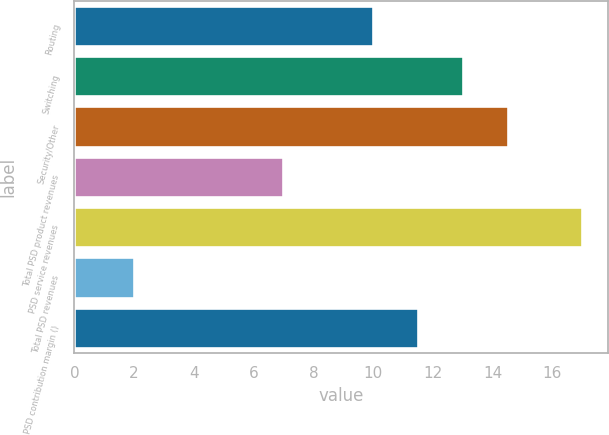Convert chart to OTSL. <chart><loc_0><loc_0><loc_500><loc_500><bar_chart><fcel>Routing<fcel>Switching<fcel>Security/Other<fcel>Total PSD product revenues<fcel>PSD service revenues<fcel>Total PSD revenues<fcel>PSD contribution margin ()<nl><fcel>10<fcel>13<fcel>14.5<fcel>7<fcel>17<fcel>2<fcel>11.5<nl></chart> 